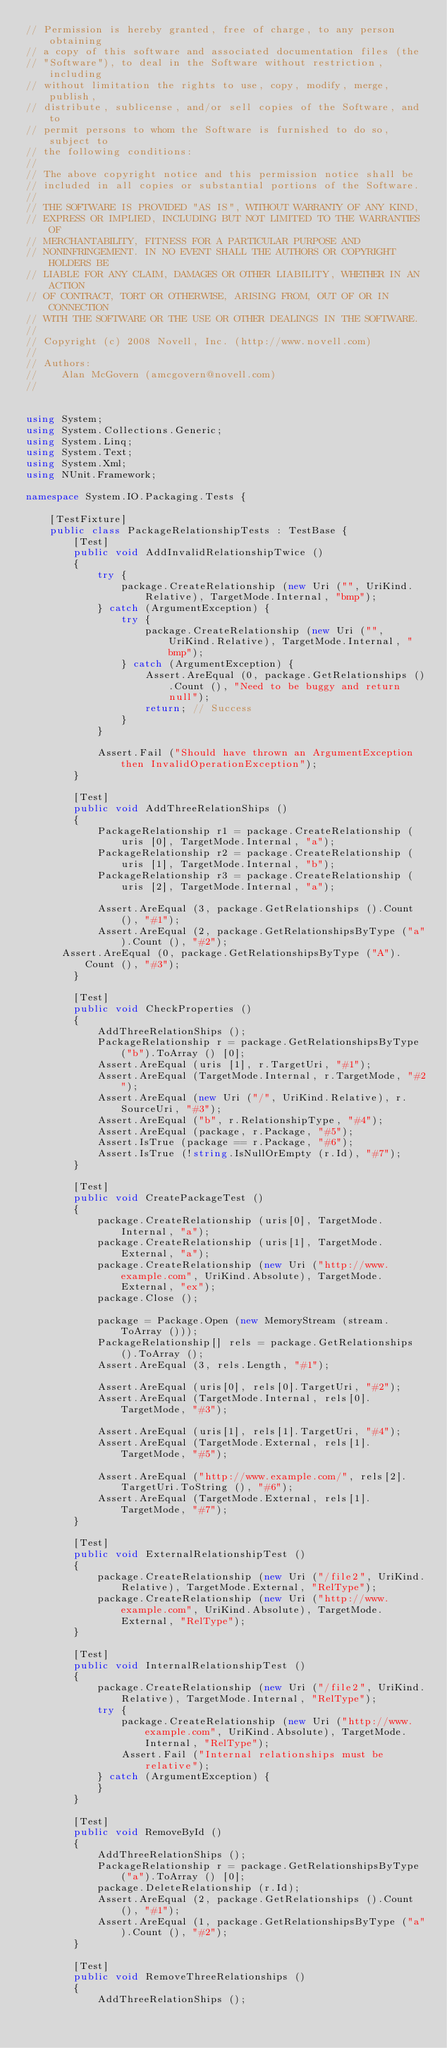Convert code to text. <code><loc_0><loc_0><loc_500><loc_500><_C#_>// Permission is hereby granted, free of charge, to any person obtaining
// a copy of this software and associated documentation files (the
// "Software"), to deal in the Software without restriction, including
// without limitation the rights to use, copy, modify, merge, publish,
// distribute, sublicense, and/or sell copies of the Software, and to
// permit persons to whom the Software is furnished to do so, subject to
// the following conditions:
// 
// The above copyright notice and this permission notice shall be
// included in all copies or substantial portions of the Software.
// 
// THE SOFTWARE IS PROVIDED "AS IS", WITHOUT WARRANTY OF ANY KIND,
// EXPRESS OR IMPLIED, INCLUDING BUT NOT LIMITED TO THE WARRANTIES OF
// MERCHANTABILITY, FITNESS FOR A PARTICULAR PURPOSE AND
// NONINFRINGEMENT. IN NO EVENT SHALL THE AUTHORS OR COPYRIGHT HOLDERS BE
// LIABLE FOR ANY CLAIM, DAMAGES OR OTHER LIABILITY, WHETHER IN AN ACTION
// OF CONTRACT, TORT OR OTHERWISE, ARISING FROM, OUT OF OR IN CONNECTION
// WITH THE SOFTWARE OR THE USE OR OTHER DEALINGS IN THE SOFTWARE.
//
// Copyright (c) 2008 Novell, Inc. (http://www.novell.com)
//
// Authors:
//    Alan McGovern (amcgovern@novell.com)
//


using System;
using System.Collections.Generic;
using System.Linq;
using System.Text;
using System.Xml;
using NUnit.Framework;

namespace System.IO.Packaging.Tests {
    
    [TestFixture]
    public class PackageRelationshipTests : TestBase {
        [Test]
        public void AddInvalidRelationshipTwice ()
        {
            try {
                package.CreateRelationship (new Uri ("", UriKind.Relative), TargetMode.Internal, "bmp");
            } catch (ArgumentException) {
                try {
                    package.CreateRelationship (new Uri ("", UriKind.Relative), TargetMode.Internal, "bmp");
                } catch (ArgumentException) {
                    Assert.AreEqual (0, package.GetRelationships ().Count (), "Need to be buggy and return null");
                    return; // Success
                }
            }

            Assert.Fail ("Should have thrown an ArgumentException then InvalidOperationException");
        }

        [Test]
        public void AddThreeRelationShips ()
        {
            PackageRelationship r1 = package.CreateRelationship (uris [0], TargetMode.Internal, "a");
            PackageRelationship r2 = package.CreateRelationship (uris [1], TargetMode.Internal, "b");
            PackageRelationship r3 = package.CreateRelationship (uris [2], TargetMode.Internal, "a");

            Assert.AreEqual (3, package.GetRelationships ().Count (), "#1");
            Assert.AreEqual (2, package.GetRelationshipsByType ("a").Count (), "#2");
			Assert.AreEqual (0, package.GetRelationshipsByType ("A").Count (), "#3");
        }

        [Test]
        public void CheckProperties ()
        {
            AddThreeRelationShips ();
            PackageRelationship r = package.GetRelationshipsByType ("b").ToArray () [0];
            Assert.AreEqual (uris [1], r.TargetUri, "#1");
            Assert.AreEqual (TargetMode.Internal, r.TargetMode, "#2");
            Assert.AreEqual (new Uri ("/", UriKind.Relative), r.SourceUri, "#3");
            Assert.AreEqual ("b", r.RelationshipType, "#4");
            Assert.AreEqual (package, r.Package, "#5");
            Assert.IsTrue (package == r.Package, "#6");
            Assert.IsTrue (!string.IsNullOrEmpty (r.Id), "#7");
        }

        [Test]
        public void CreatePackageTest ()
        {
            package.CreateRelationship (uris[0], TargetMode.Internal, "a");
            package.CreateRelationship (uris[1], TargetMode.External, "a");
            package.CreateRelationship (new Uri ("http://www.example.com", UriKind.Absolute), TargetMode.External, "ex");
            package.Close ();

            package = Package.Open (new MemoryStream (stream.ToArray ()));
            PackageRelationship[] rels = package.GetRelationships ().ToArray ();
            Assert.AreEqual (3, rels.Length, "#1");

            Assert.AreEqual (uris[0], rels[0].TargetUri, "#2");
            Assert.AreEqual (TargetMode.Internal, rels[0].TargetMode, "#3");

            Assert.AreEqual (uris[1], rels[1].TargetUri, "#4");
            Assert.AreEqual (TargetMode.External, rels[1].TargetMode, "#5");

            Assert.AreEqual ("http://www.example.com/", rels[2].TargetUri.ToString (), "#6");
            Assert.AreEqual (TargetMode.External, rels[1].TargetMode, "#7");
        }

        [Test]
        public void ExternalRelationshipTest ()
        {
            package.CreateRelationship (new Uri ("/file2", UriKind.Relative), TargetMode.External, "RelType");
            package.CreateRelationship (new Uri ("http://www.example.com", UriKind.Absolute), TargetMode.External, "RelType");
        }

        [Test]
        public void InternalRelationshipTest ()
        {
            package.CreateRelationship (new Uri ("/file2", UriKind.Relative), TargetMode.Internal, "RelType");
            try {
                package.CreateRelationship (new Uri ("http://www.example.com", UriKind.Absolute), TargetMode.Internal, "RelType");
                Assert.Fail ("Internal relationships must be relative");
            } catch (ArgumentException) {
            }
        }

        [Test]
        public void RemoveById ()
        {
            AddThreeRelationShips ();
            PackageRelationship r = package.GetRelationshipsByType ("a").ToArray () [0];
            package.DeleteRelationship (r.Id);
            Assert.AreEqual (2, package.GetRelationships ().Count (), "#1");
            Assert.AreEqual (1, package.GetRelationshipsByType ("a").Count (), "#2");
        }

        [Test]
        public void RemoveThreeRelationships ()
        {
            AddThreeRelationShips ();</code> 